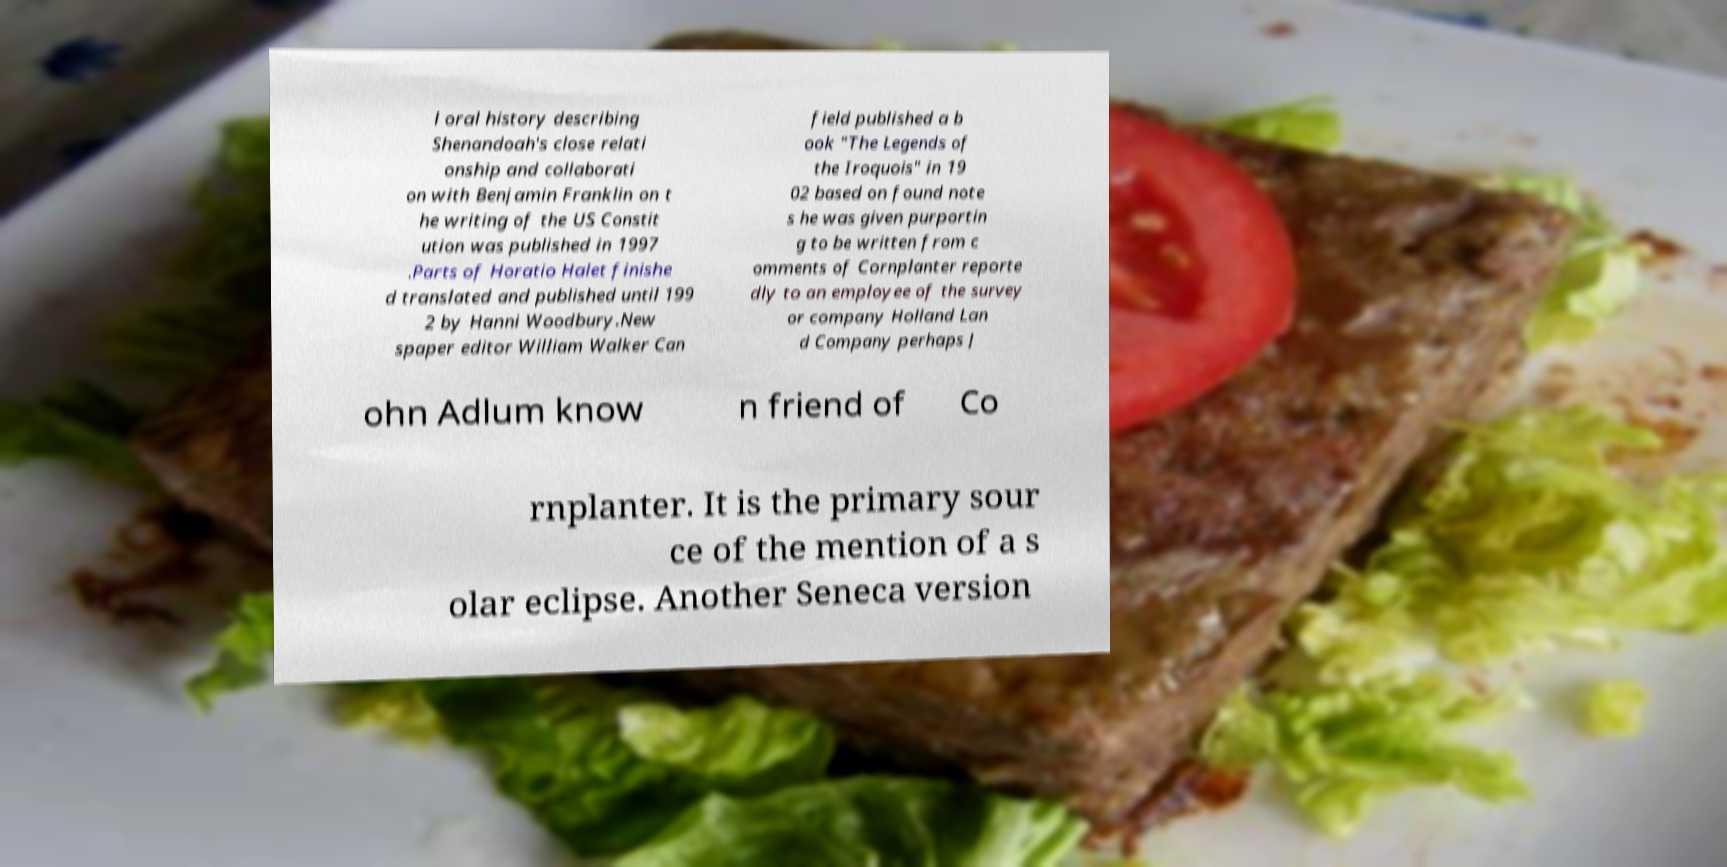Can you accurately transcribe the text from the provided image for me? l oral history describing Shenandoah's close relati onship and collaborati on with Benjamin Franklin on t he writing of the US Constit ution was published in 1997 .Parts of Horatio Halet finishe d translated and published until 199 2 by Hanni Woodbury.New spaper editor William Walker Can field published a b ook "The Legends of the Iroquois" in 19 02 based on found note s he was given purportin g to be written from c omments of Cornplanter reporte dly to an employee of the survey or company Holland Lan d Company perhaps J ohn Adlum know n friend of Co rnplanter. It is the primary sour ce of the mention of a s olar eclipse. Another Seneca version 